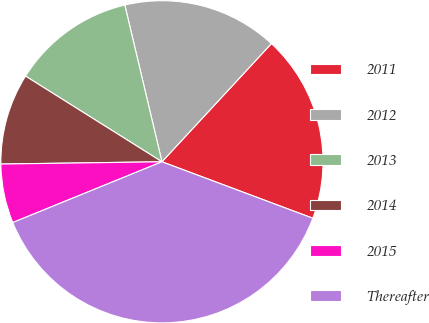<chart> <loc_0><loc_0><loc_500><loc_500><pie_chart><fcel>2011<fcel>2012<fcel>2013<fcel>2014<fcel>2015<fcel>Thereafter<nl><fcel>18.81%<fcel>15.59%<fcel>12.37%<fcel>9.15%<fcel>5.93%<fcel>38.14%<nl></chart> 